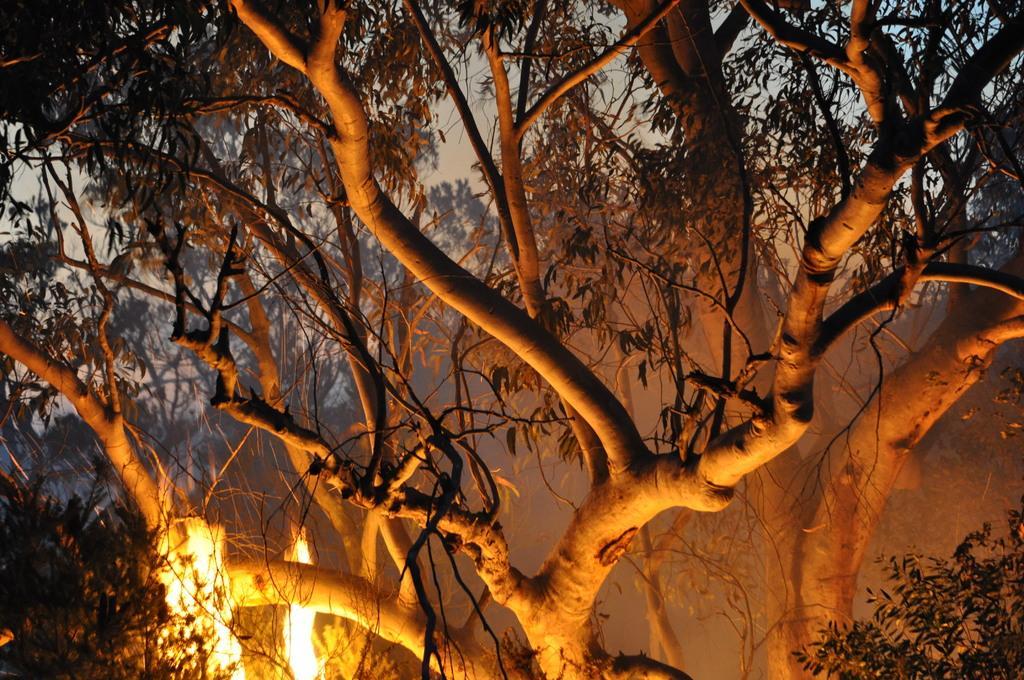Please provide a concise description of this image. In this image we can see trees and the sky is present in the background. 